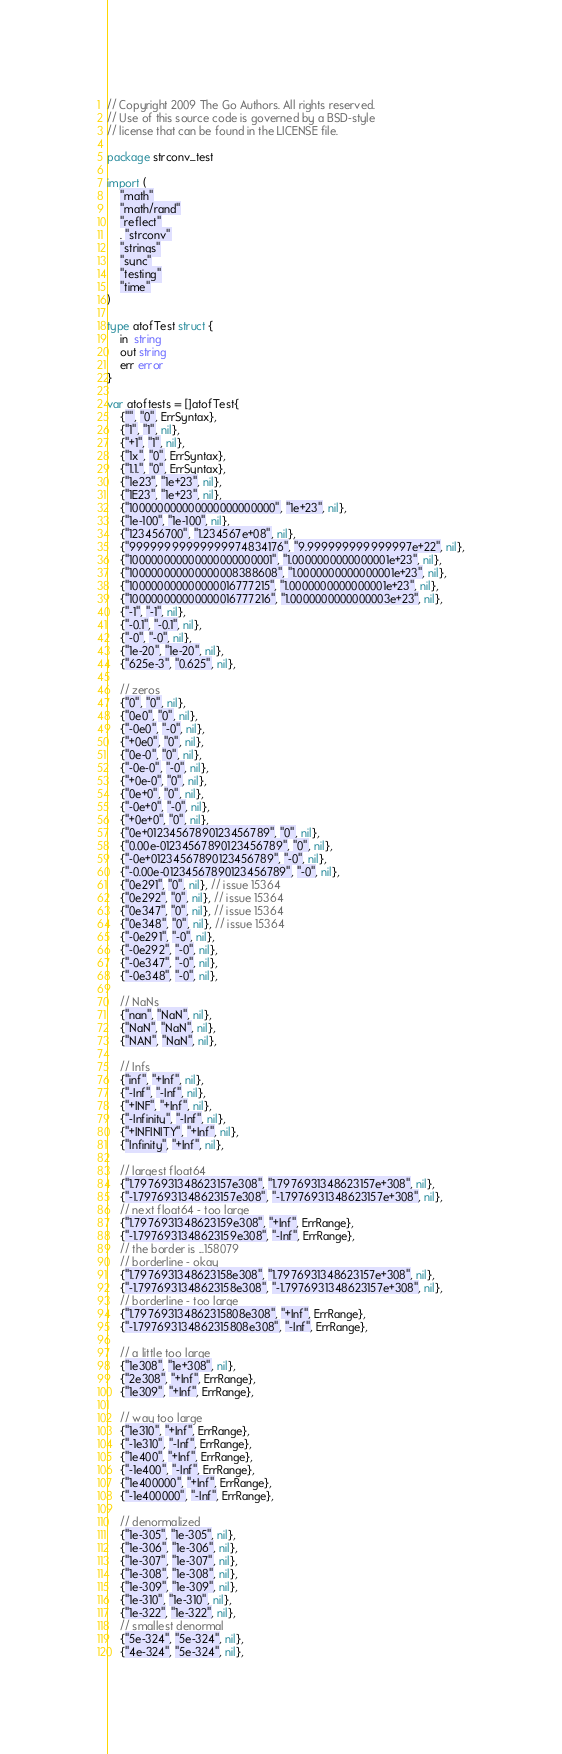Convert code to text. <code><loc_0><loc_0><loc_500><loc_500><_Go_>// Copyright 2009 The Go Authors. All rights reserved.
// Use of this source code is governed by a BSD-style
// license that can be found in the LICENSE file.

package strconv_test

import (
	"math"
	"math/rand"
	"reflect"
	. "strconv"
	"strings"
	"sync"
	"testing"
	"time"
)

type atofTest struct {
	in  string
	out string
	err error
}

var atoftests = []atofTest{
	{"", "0", ErrSyntax},
	{"1", "1", nil},
	{"+1", "1", nil},
	{"1x", "0", ErrSyntax},
	{"1.1.", "0", ErrSyntax},
	{"1e23", "1e+23", nil},
	{"1E23", "1e+23", nil},
	{"100000000000000000000000", "1e+23", nil},
	{"1e-100", "1e-100", nil},
	{"123456700", "1.234567e+08", nil},
	{"99999999999999974834176", "9.999999999999997e+22", nil},
	{"100000000000000000000001", "1.0000000000000001e+23", nil},
	{"100000000000000008388608", "1.0000000000000001e+23", nil},
	{"100000000000000016777215", "1.0000000000000001e+23", nil},
	{"100000000000000016777216", "1.0000000000000003e+23", nil},
	{"-1", "-1", nil},
	{"-0.1", "-0.1", nil},
	{"-0", "-0", nil},
	{"1e-20", "1e-20", nil},
	{"625e-3", "0.625", nil},

	// zeros
	{"0", "0", nil},
	{"0e0", "0", nil},
	{"-0e0", "-0", nil},
	{"+0e0", "0", nil},
	{"0e-0", "0", nil},
	{"-0e-0", "-0", nil},
	{"+0e-0", "0", nil},
	{"0e+0", "0", nil},
	{"-0e+0", "-0", nil},
	{"+0e+0", "0", nil},
	{"0e+01234567890123456789", "0", nil},
	{"0.00e-01234567890123456789", "0", nil},
	{"-0e+01234567890123456789", "-0", nil},
	{"-0.00e-01234567890123456789", "-0", nil},
	{"0e291", "0", nil}, // issue 15364
	{"0e292", "0", nil}, // issue 15364
	{"0e347", "0", nil}, // issue 15364
	{"0e348", "0", nil}, // issue 15364
	{"-0e291", "-0", nil},
	{"-0e292", "-0", nil},
	{"-0e347", "-0", nil},
	{"-0e348", "-0", nil},

	// NaNs
	{"nan", "NaN", nil},
	{"NaN", "NaN", nil},
	{"NAN", "NaN", nil},

	// Infs
	{"inf", "+Inf", nil},
	{"-Inf", "-Inf", nil},
	{"+INF", "+Inf", nil},
	{"-Infinity", "-Inf", nil},
	{"+INFINITY", "+Inf", nil},
	{"Infinity", "+Inf", nil},

	// largest float64
	{"1.7976931348623157e308", "1.7976931348623157e+308", nil},
	{"-1.7976931348623157e308", "-1.7976931348623157e+308", nil},
	// next float64 - too large
	{"1.7976931348623159e308", "+Inf", ErrRange},
	{"-1.7976931348623159e308", "-Inf", ErrRange},
	// the border is ...158079
	// borderline - okay
	{"1.7976931348623158e308", "1.7976931348623157e+308", nil},
	{"-1.7976931348623158e308", "-1.7976931348623157e+308", nil},
	// borderline - too large
	{"1.797693134862315808e308", "+Inf", ErrRange},
	{"-1.797693134862315808e308", "-Inf", ErrRange},

	// a little too large
	{"1e308", "1e+308", nil},
	{"2e308", "+Inf", ErrRange},
	{"1e309", "+Inf", ErrRange},

	// way too large
	{"1e310", "+Inf", ErrRange},
	{"-1e310", "-Inf", ErrRange},
	{"1e400", "+Inf", ErrRange},
	{"-1e400", "-Inf", ErrRange},
	{"1e400000", "+Inf", ErrRange},
	{"-1e400000", "-Inf", ErrRange},

	// denormalized
	{"1e-305", "1e-305", nil},
	{"1e-306", "1e-306", nil},
	{"1e-307", "1e-307", nil},
	{"1e-308", "1e-308", nil},
	{"1e-309", "1e-309", nil},
	{"1e-310", "1e-310", nil},
	{"1e-322", "1e-322", nil},
	// smallest denormal
	{"5e-324", "5e-324", nil},
	{"4e-324", "5e-324", nil},</code> 